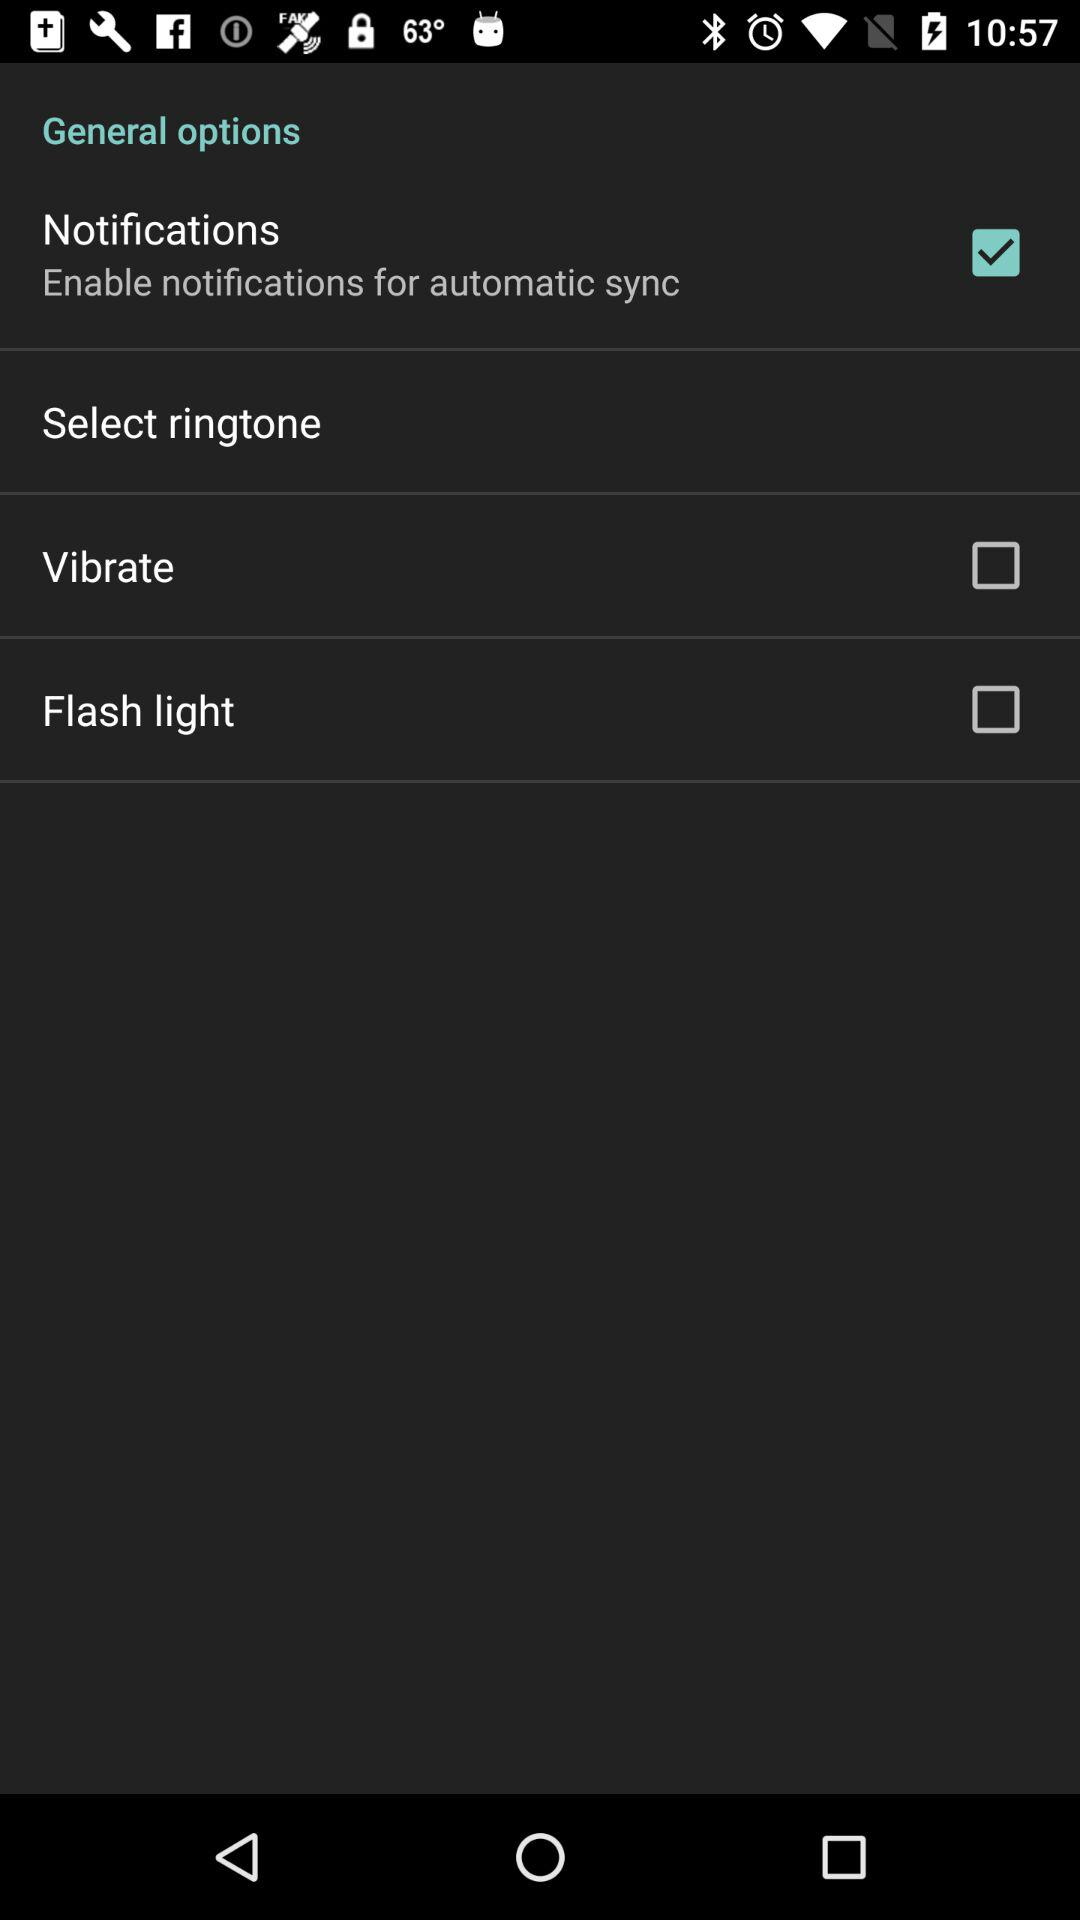What is the status of "Flash light"? The status is "off". 